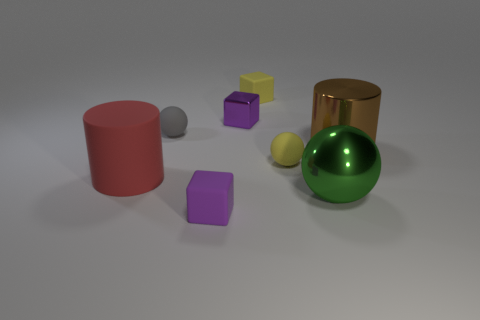Is there any pattern or symmetry in the arrangement of the objects? The arrangement of the objects doesn't follow a strict pattern or symmetry. They are placed somewhat randomly on the surface, but the composition is balanced with a mix of shapes and colors. There's a variety in size and texture as well from smooth and shiny to matte, which adds to the visual interest of the scene. 